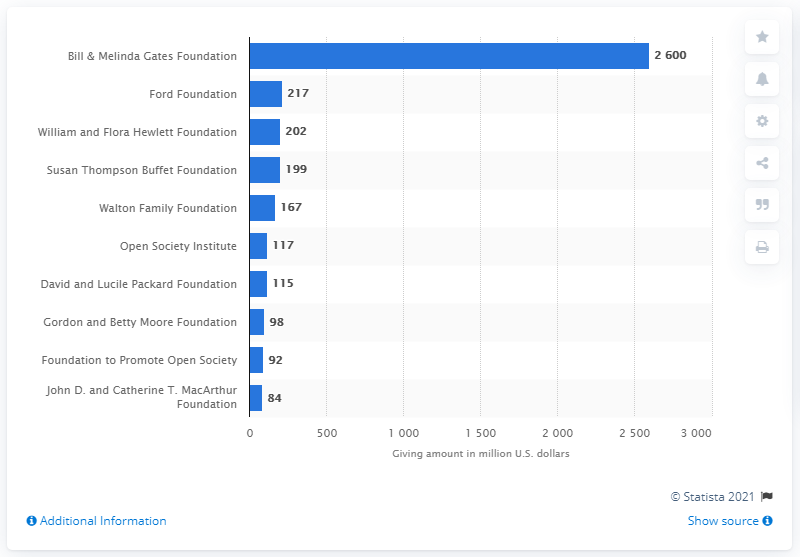Mention a couple of crucial points in this snapshot. The Bill and Melinda Gates Foundation gave a significant amount of money in 2013, specifically 2600. 